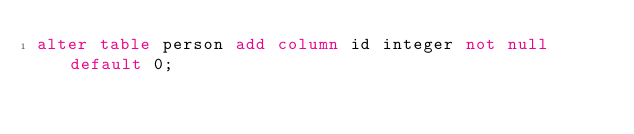<code> <loc_0><loc_0><loc_500><loc_500><_SQL_>alter table person add column id integer not null default 0;
</code> 